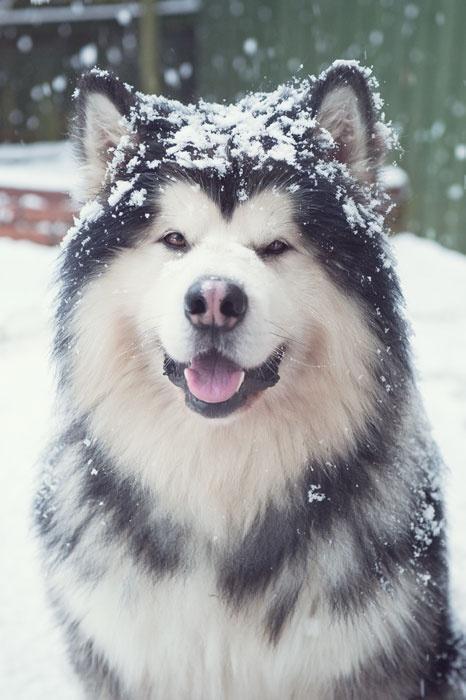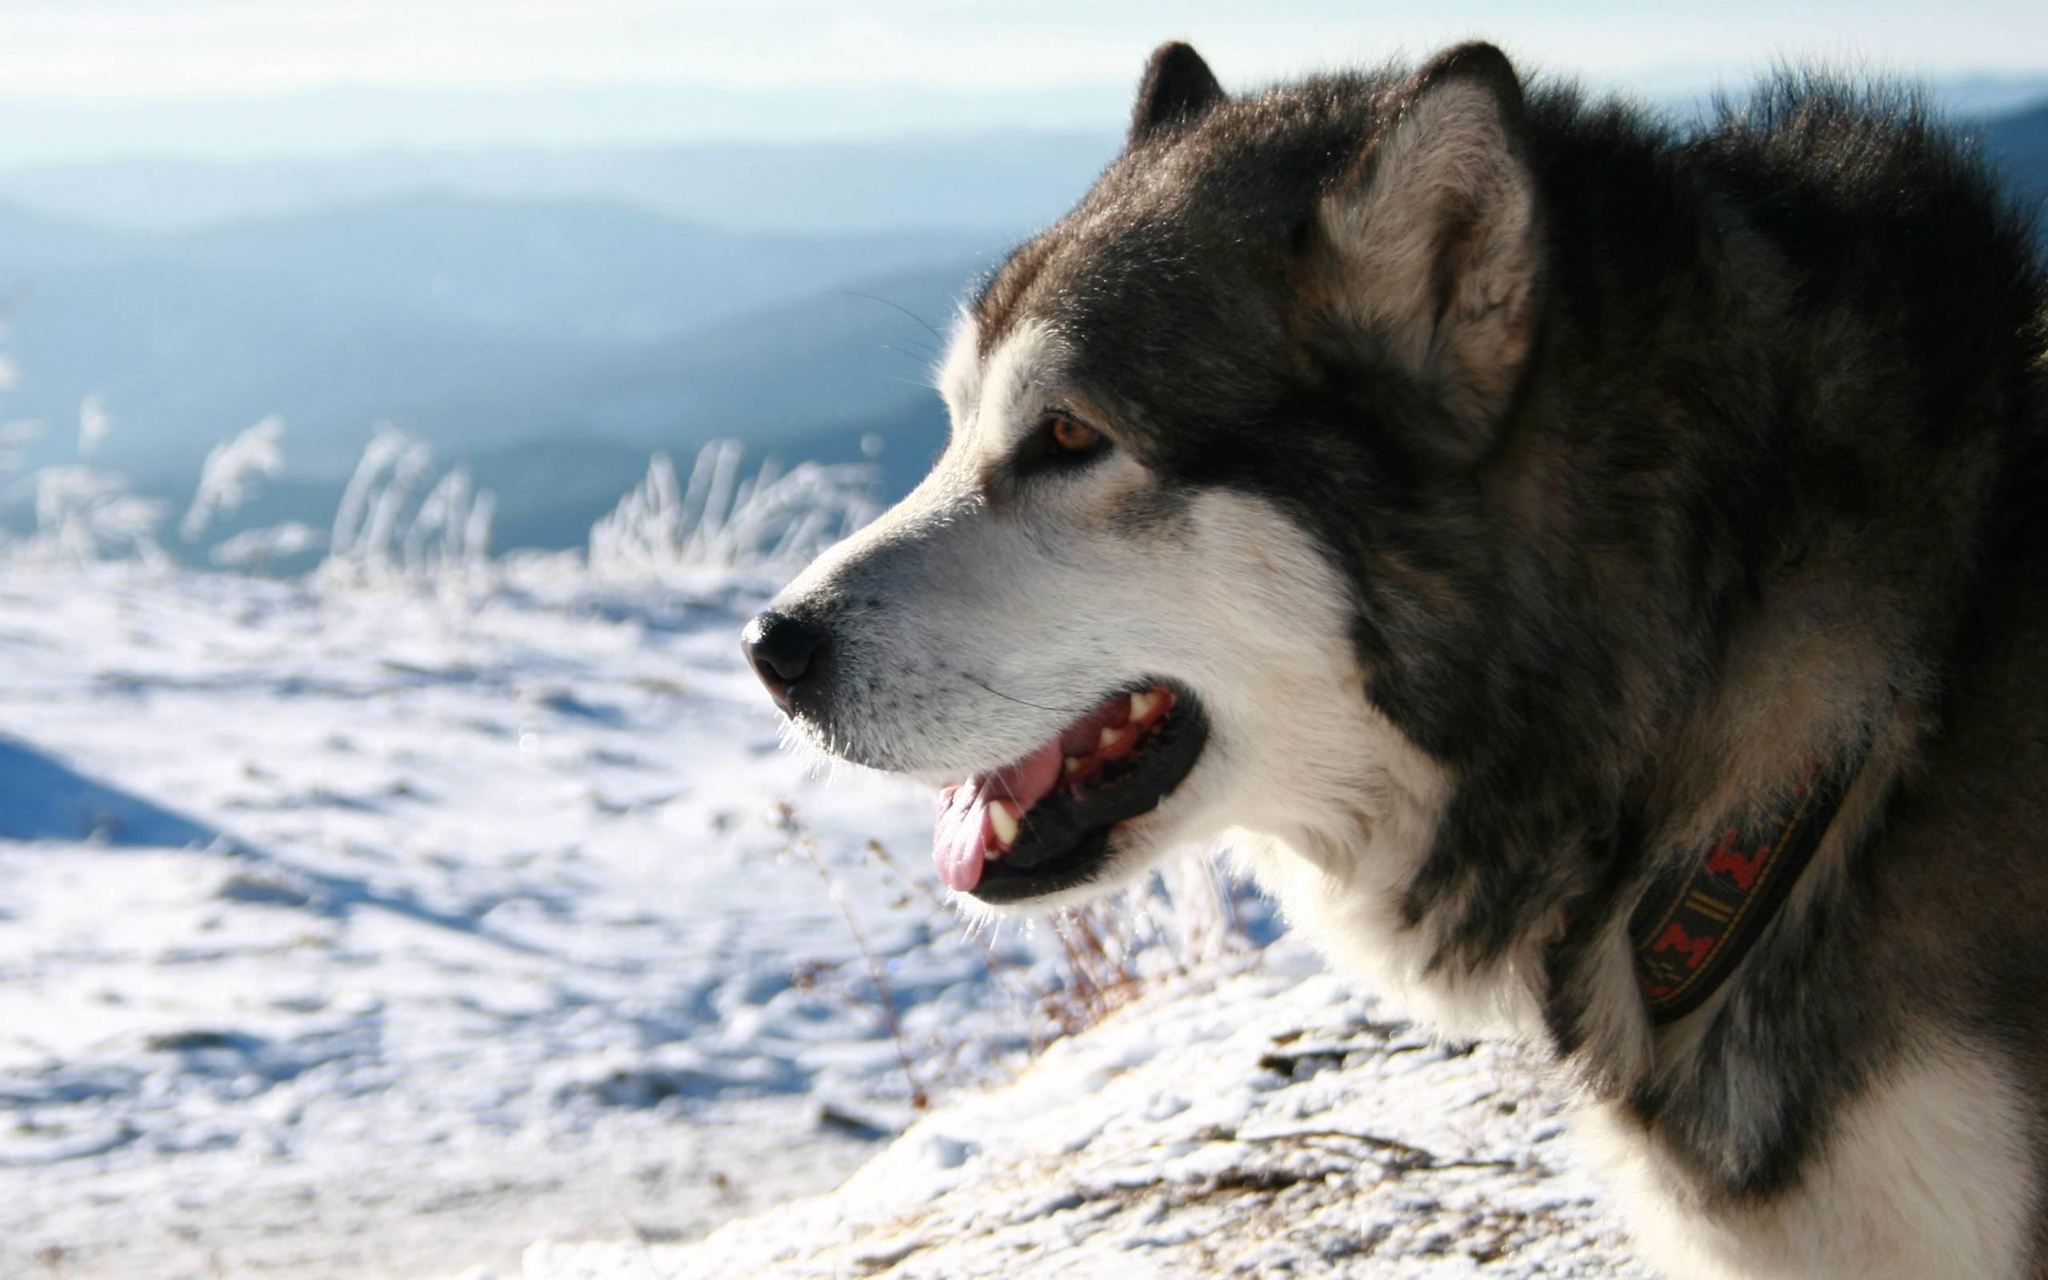The first image is the image on the left, the second image is the image on the right. Examine the images to the left and right. Is the description "There is a dog with its mouth open in each image." accurate? Answer yes or no. Yes. The first image is the image on the left, the second image is the image on the right. Evaluate the accuracy of this statement regarding the images: "One husky has its mouth open but is not snarling, and a different husky wears something blue around itself and has upright ears.". Is it true? Answer yes or no. No. 